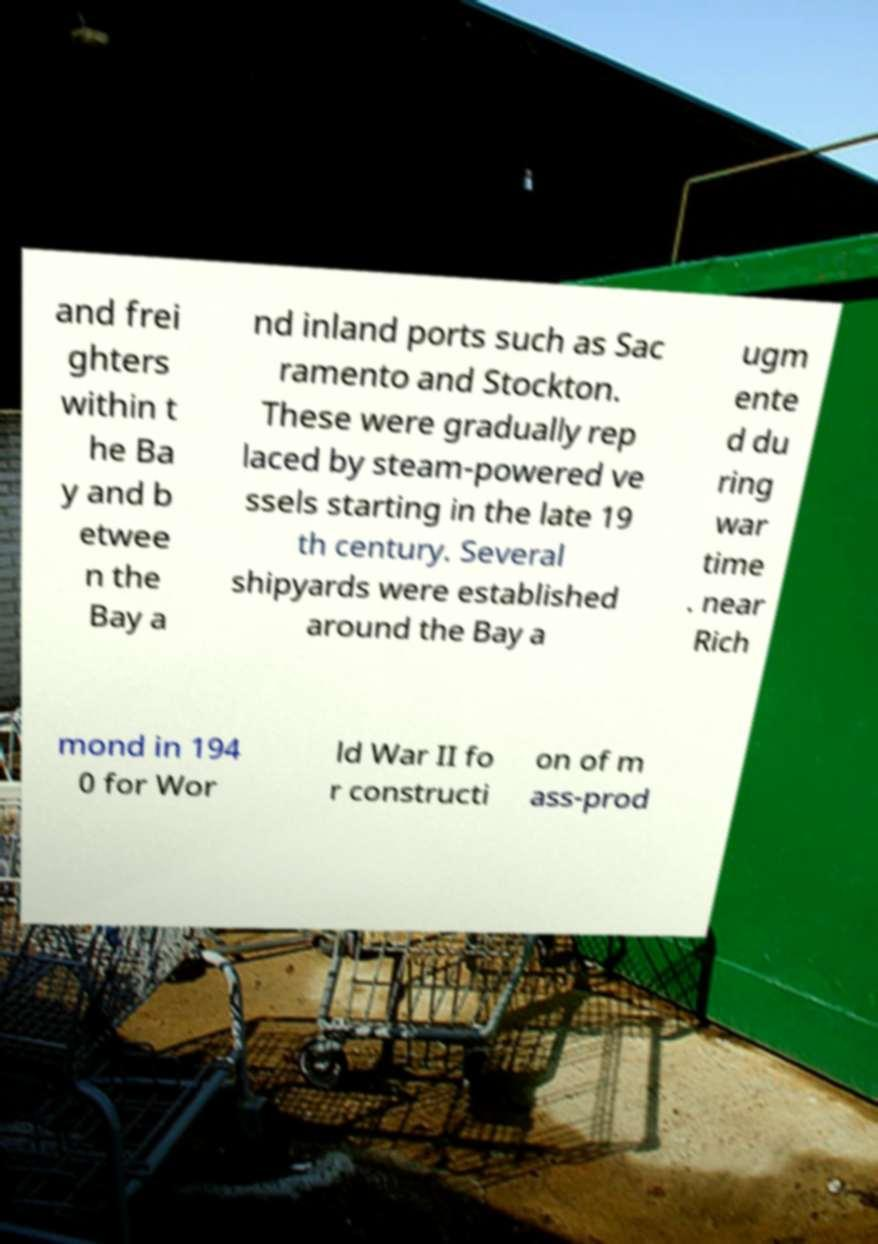Please read and relay the text visible in this image. What does it say? and frei ghters within t he Ba y and b etwee n the Bay a nd inland ports such as Sac ramento and Stockton. These were gradually rep laced by steam-powered ve ssels starting in the late 19 th century. Several shipyards were established around the Bay a ugm ente d du ring war time . near Rich mond in 194 0 for Wor ld War II fo r constructi on of m ass-prod 